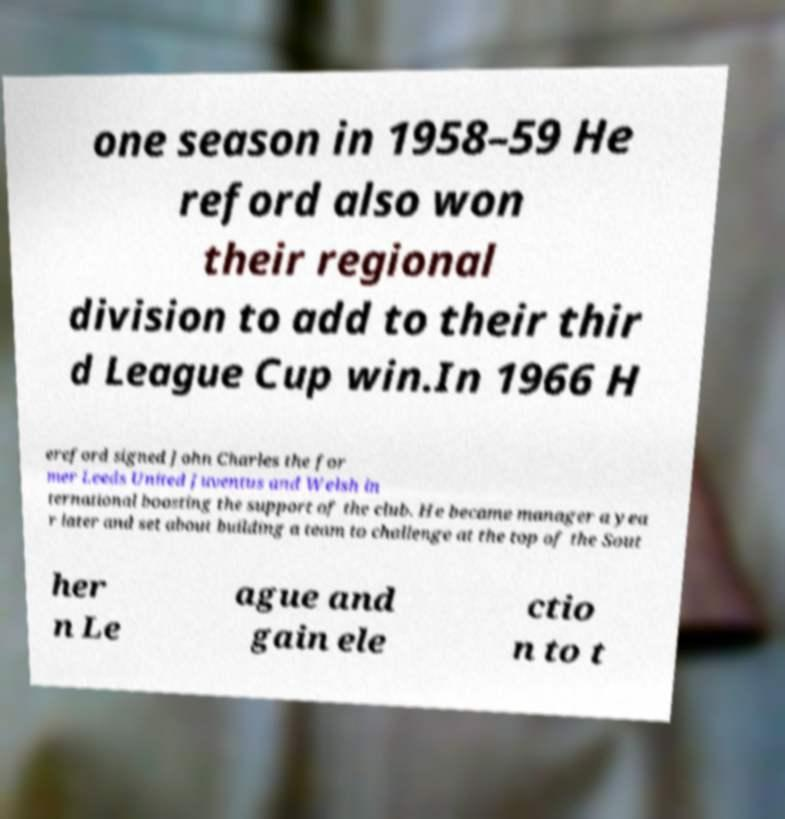Can you accurately transcribe the text from the provided image for me? one season in 1958–59 He reford also won their regional division to add to their thir d League Cup win.In 1966 H ereford signed John Charles the for mer Leeds United Juventus and Welsh in ternational boosting the support of the club. He became manager a yea r later and set about building a team to challenge at the top of the Sout her n Le ague and gain ele ctio n to t 